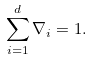<formula> <loc_0><loc_0><loc_500><loc_500>\sum _ { i = 1 } ^ { d } \nabla _ { i } = 1 .</formula> 